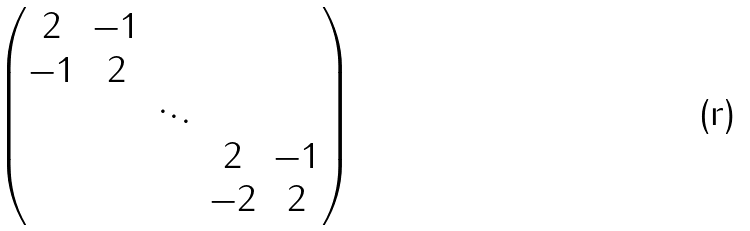Convert formula to latex. <formula><loc_0><loc_0><loc_500><loc_500>\begin{pmatrix} 2 & - 1 \\ - 1 & 2 \\ & & \ddots \\ & & & 2 & - 1 \\ & & & - 2 & 2 \end{pmatrix}</formula> 